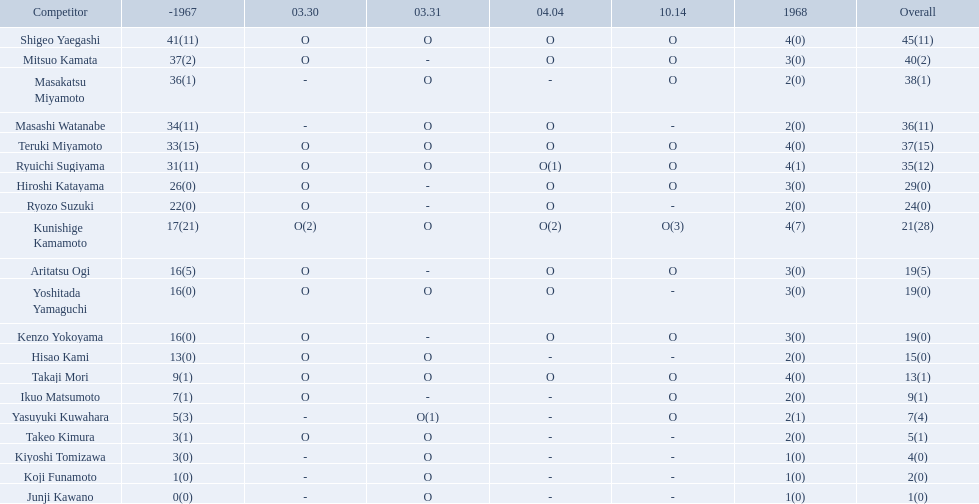Who were the players in the 1968 japanese football? Shigeo Yaegashi, Mitsuo Kamata, Masakatsu Miyamoto, Masashi Watanabe, Teruki Miyamoto, Ryuichi Sugiyama, Hiroshi Katayama, Ryozo Suzuki, Kunishige Kamamoto, Aritatsu Ogi, Yoshitada Yamaguchi, Kenzo Yokoyama, Hisao Kami, Takaji Mori, Ikuo Matsumoto, Yasuyuki Kuwahara, Takeo Kimura, Kiyoshi Tomizawa, Koji Funamoto, Junji Kawano. How many points total did takaji mori have? 13(1). How many points total did junju kawano? 1(0). Who had more points? Takaji Mori. How many points did takaji mori have? 13(1). And how many points did junji kawano have? 1(0). To who does the higher of these belong to? Takaji Mori. 